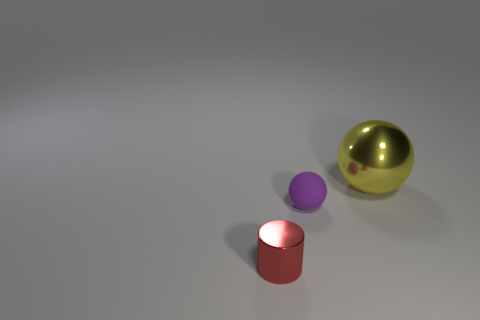Are there more purple matte objects to the right of the big yellow metal object than shiny blocks?
Your answer should be compact. No. Are there any small cylinders?
Provide a succinct answer. Yes. How many other objects are there of the same shape as the rubber object?
Ensure brevity in your answer.  1. There is a metallic object that is on the right side of the rubber object; does it have the same color as the small object that is on the right side of the small red metallic object?
Your answer should be very brief. No. There is a sphere in front of the shiny object right of the shiny thing that is in front of the big yellow shiny ball; what size is it?
Give a very brief answer. Small. There is a thing that is both behind the small red metal thing and in front of the big thing; what is its shape?
Your response must be concise. Sphere. Is the number of small spheres in front of the matte sphere the same as the number of big yellow metallic objects left of the yellow metal object?
Offer a very short reply. Yes. Are there any large yellow things that have the same material as the tiny red thing?
Ensure brevity in your answer.  Yes. Does the thing that is on the right side of the small purple matte object have the same material as the small purple thing?
Give a very brief answer. No. What size is the thing that is both behind the red shiny cylinder and in front of the yellow shiny thing?
Your response must be concise. Small. 